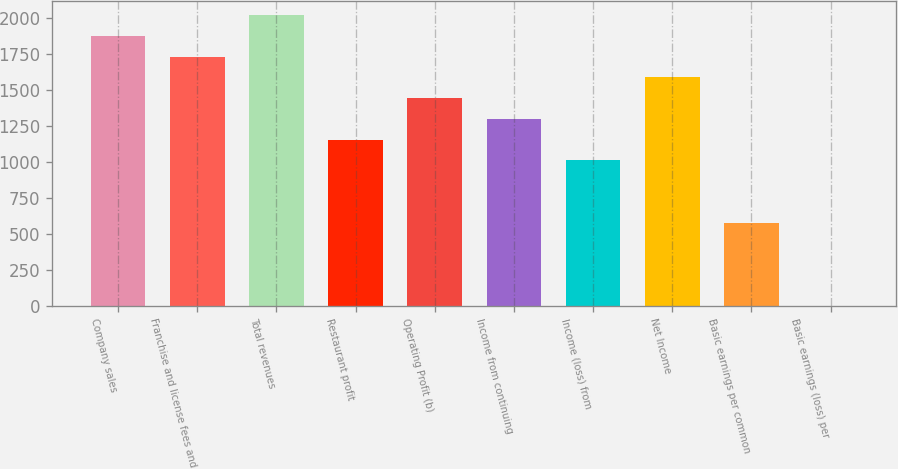Convert chart. <chart><loc_0><loc_0><loc_500><loc_500><bar_chart><fcel>Company sales<fcel>Franchise and license fees and<fcel>Total revenues<fcel>Restaurant profit<fcel>Operating Profit (b)<fcel>Income from continuing<fcel>Income (loss) from<fcel>Net Income<fcel>Basic earnings per common<fcel>Basic earnings (loss) per<nl><fcel>1875.84<fcel>1731.57<fcel>2020.11<fcel>1154.49<fcel>1443.03<fcel>1298.76<fcel>1010.22<fcel>1587.3<fcel>577.41<fcel>0.33<nl></chart> 